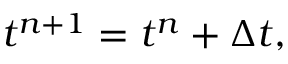<formula> <loc_0><loc_0><loc_500><loc_500>t ^ { n + 1 } = t ^ { n } + { \Delta t } ,</formula> 